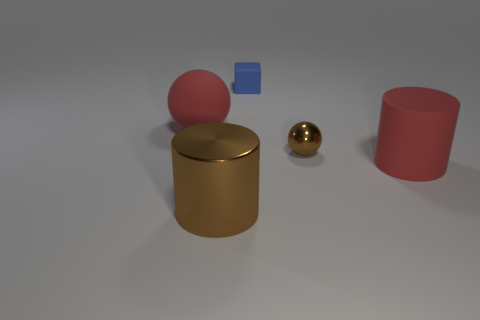Add 5 small gray metal balls. How many objects exist? 10 Subtract 1 red spheres. How many objects are left? 4 Subtract all cylinders. How many objects are left? 3 Subtract all big red rubber spheres. Subtract all red spheres. How many objects are left? 3 Add 1 tiny things. How many tiny things are left? 3 Add 5 brown shiny spheres. How many brown shiny spheres exist? 6 